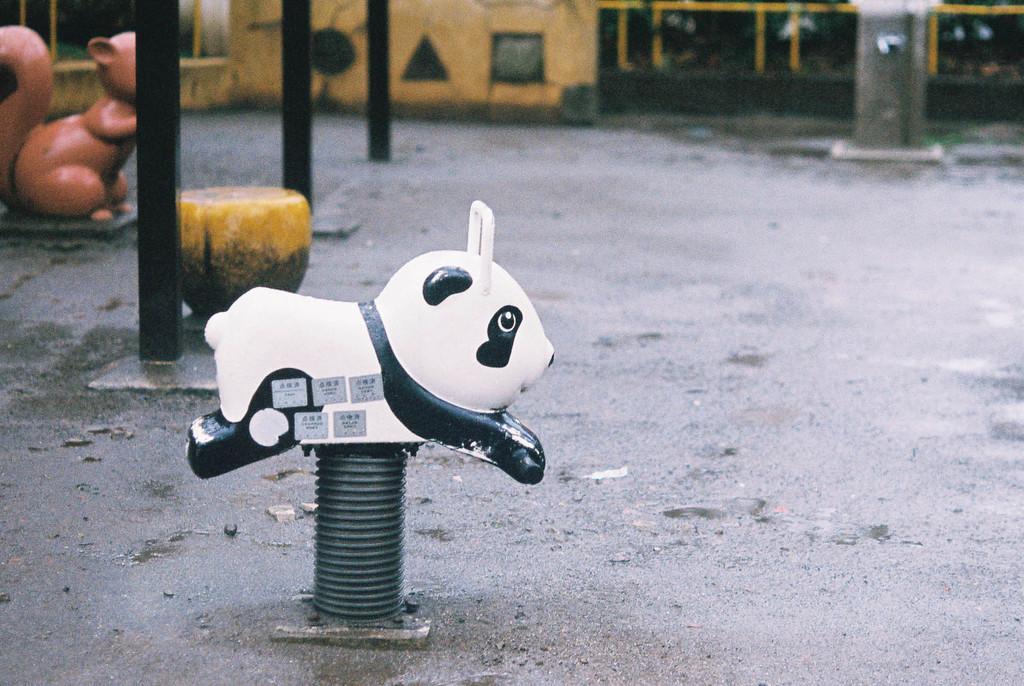Please provide a concise description of this image. This picture is clicked outside. On the left there is a white color panda attached to the spring which is attached to the ground and there is a yellow color object placed on the ground and we can see the poles and a toy of a squirrel. In the background we can see the buildings and some other objects. 